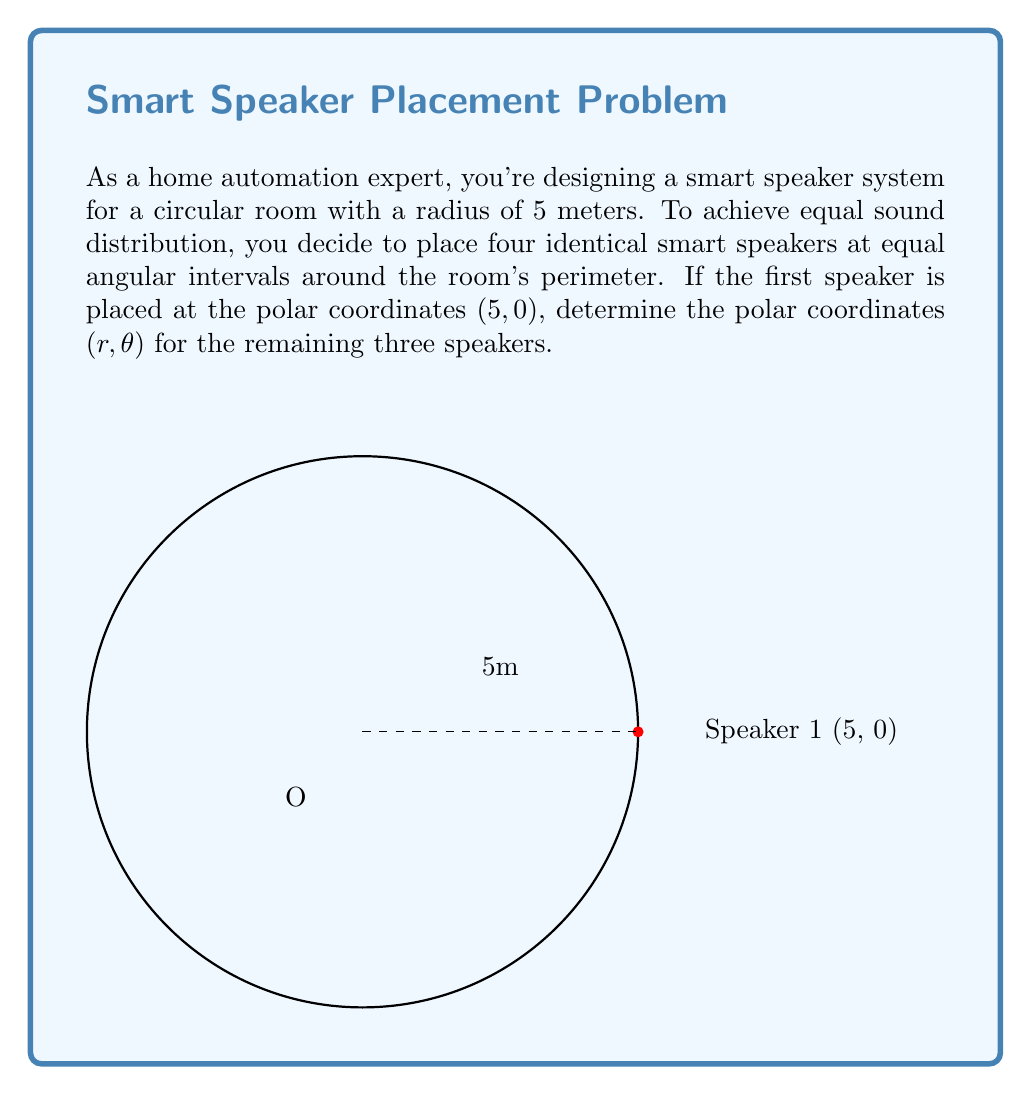Teach me how to tackle this problem. Let's approach this step-by-step:

1) In a circular room, to achieve equal sound distribution with four speakers, we need to place them at 90° intervals (360° ÷ 4 = 90°).

2) We're given that the first speaker is at $(5, 0)$. This means:
   - The radius (r) for all speakers will be 5 meters (the room's radius).
   - The angles (θ) will be in multiples of 90°.

3) Let's calculate the polar coordinates for each speaker:

   Speaker 1: Already given as $(5, 0)$
   
   Speaker 2: 
   - r = 5
   - θ = 90° = $\frac{\pi}{2}$ radians
   
   Speaker 3:
   - r = 5
   - θ = 180° = $\pi$ radians
   
   Speaker 4:
   - r = 5
   - θ = 270° = $\frac{3\pi}{2}$ radians

4) Therefore, the polar coordinates $(r, \theta)$ for the remaining three speakers are:
   
   Speaker 2: $(5, \frac{\pi}{2})$
   Speaker 3: $(5, \pi)$
   Speaker 4: $(5, \frac{3\pi}{2})$
Answer: $(5, \frac{\pi}{2})$, $(5, \pi)$, $(5, \frac{3\pi}{2})$ 